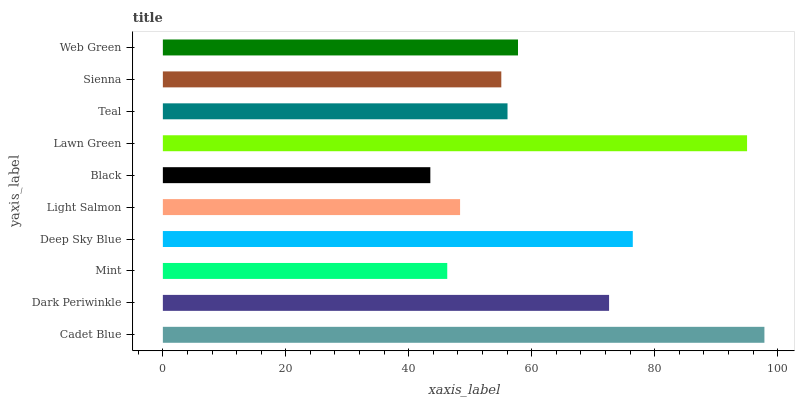Is Black the minimum?
Answer yes or no. Yes. Is Cadet Blue the maximum?
Answer yes or no. Yes. Is Dark Periwinkle the minimum?
Answer yes or no. No. Is Dark Periwinkle the maximum?
Answer yes or no. No. Is Cadet Blue greater than Dark Periwinkle?
Answer yes or no. Yes. Is Dark Periwinkle less than Cadet Blue?
Answer yes or no. Yes. Is Dark Periwinkle greater than Cadet Blue?
Answer yes or no. No. Is Cadet Blue less than Dark Periwinkle?
Answer yes or no. No. Is Web Green the high median?
Answer yes or no. Yes. Is Teal the low median?
Answer yes or no. Yes. Is Light Salmon the high median?
Answer yes or no. No. Is Dark Periwinkle the low median?
Answer yes or no. No. 